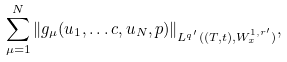Convert formula to latex. <formula><loc_0><loc_0><loc_500><loc_500>\sum ^ { N } _ { \mu = 1 } \| g _ { \mu } ( u _ { 1 } , \dots c , u _ { N } , p ) \| _ { L ^ { q ^ { \prime } } ( ( T , t ) , W ^ { 1 , r ^ { \prime } } _ { x } ) } ,</formula> 